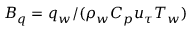Convert formula to latex. <formula><loc_0><loc_0><loc_500><loc_500>B _ { q } = q _ { w } / ( \rho _ { w } C _ { p } u _ { \tau } T _ { w } )</formula> 